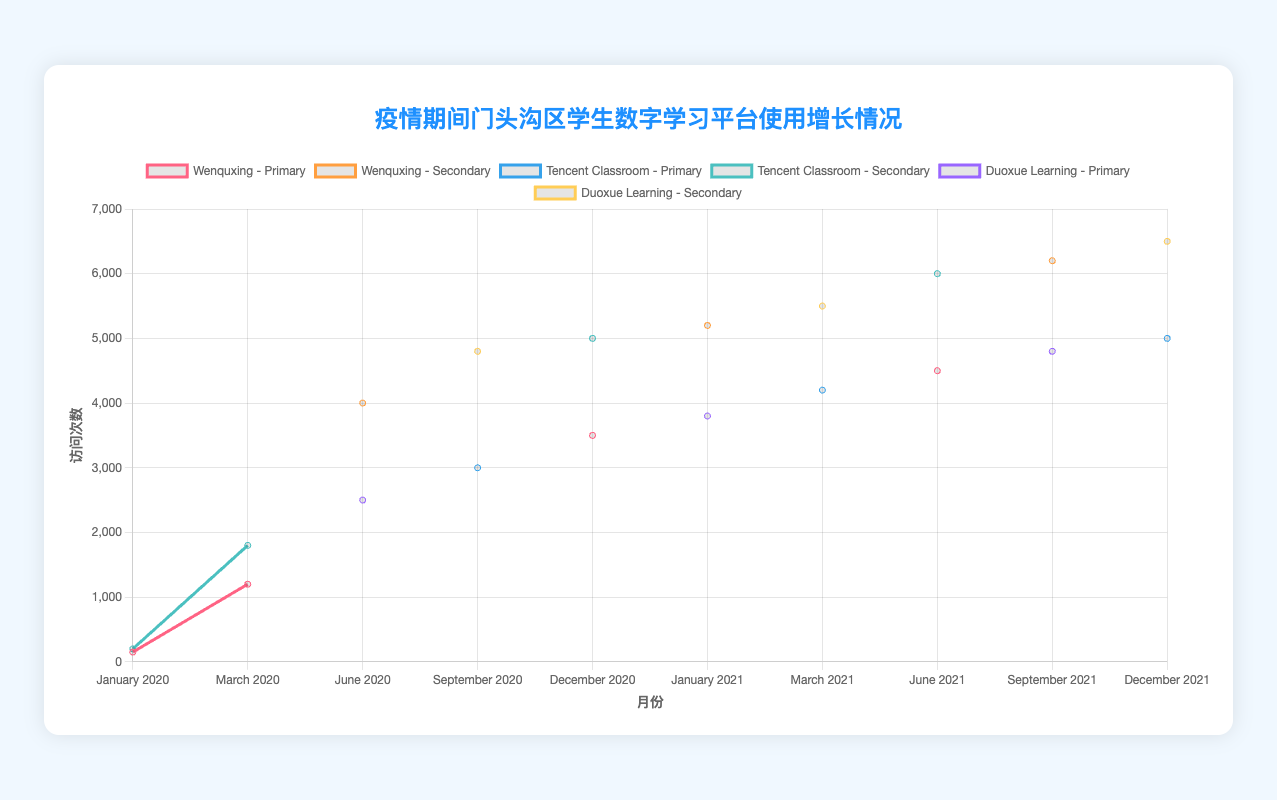What is the total access count for Tencent Classroom across all months for Secondary students? To find the total access count for Tencent Classroom for Secondary students, add the access counts for the months: January 2020 (200), March 2020 (1800), June 2020 (4000), September 2020 (3000), December 2020 (5000), January 2021 (5200), March 2021 (4200), June 2021 (6000), September 2021 (5000), December 2021 (5000). The total is 200 + 1800 + 4000 + 3000 + 5000 + 5200 + 4200 + 6000 + 5000 + 5000 = 36400.
Answer: 36400 Which platform had the highest access count in March 2021 for Secondary students? In March 2021 for Secondary students, the access counts are Duoxue Learning (5500) and Tencent Classroom (4200). Comparing these values, Duoxue Learning has the highest access count.
Answer: Duoxue Learning How does the increase in access count from January 2021 to March 2021 for Primary students compare between Tencent Classroom and Duoxue Learning? For Primary students, in January 2021, Duoxue Learning has 3800 accesses, and in March 2021, it has 4200 accesses. The increase for Duoxue Learning is 4200 - 3800 = 400. Tencent Classroom is only for Secondary students in January and March 2021. Therefore, we can only compare the increase for Duoxue Learning.
Answer: 400 What is the difference in access count for Wenquxing between Primary and Secondary students in June 2021? In June 2021, Wenquxing access counts are 4500 for Primary students and 6000 for Secondary students. The difference is 6000 - 4500 = 1500.
Answer: 1500 Which grade level and platform combination had the lowest access count in January 2020? For January 2020, the access counts are Wenquxing - Primary (150), Tencent Classroom - Secondary (200). Wenquxing for Primary grade has the lowest access count with 150 accesses.
Answer: Wenquxing - Primary By how much did the access count for Duoxue Learning increase from June 2020 to September 2021 for Primary students? For Duoxue Learning, the access count in June 2020 is 2500 for Primary students, and in September 2021, it is 4800. The increase is 4800 - 2500 = 2300.
Answer: 2300 Which platform had the largest proportional increase in access count from January 2020 to March 2020 for Primary students? Wenquxing for Primary students had an increase from 150 in January 2020 to 1200 in March 2020. The proportional increase is (1200 - 150) / 150 = 7. The other platforms are not listed for Primary students in both these months, so Wenquxing had the largest proportional increase.
Answer: Wenquxing How do the access counts compare visually for Secondary students’ platforms in December 2021? In December 2021, for Secondary students, Duoxue Learning has 6500 accesses, and Tencent Classroom has 5000 accesses. Visually, Duoxue Learning's line will be higher on the chart compared to Tencent Classroom's line.
Answer: Duoxue Learning's line is higher What trend can you observe in the access counts for Primary students using Duoxue Learning from June 2020 to December 2021? The access counts for Duoxue Learning for Primary students are 2500 in June 2020, increasing to 3800 in January 2021, 4200 in March 2021, 4800 in September 2021, and 5000 in December 2021. The trend is a steady increase in access counts over time.
Answer: Steady increase 